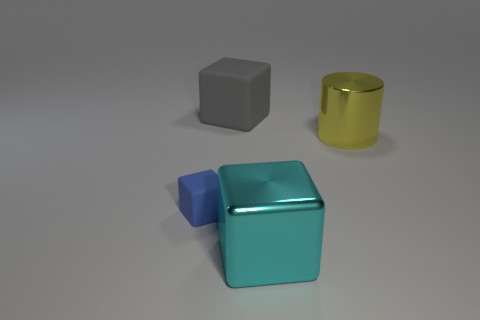Add 2 cyan things. How many objects exist? 6 Subtract all cylinders. How many objects are left? 3 Subtract 0 red cylinders. How many objects are left? 4 Subtract all gray metallic cylinders. Subtract all matte things. How many objects are left? 2 Add 1 large metal blocks. How many large metal blocks are left? 2 Add 3 brown metallic cylinders. How many brown metallic cylinders exist? 3 